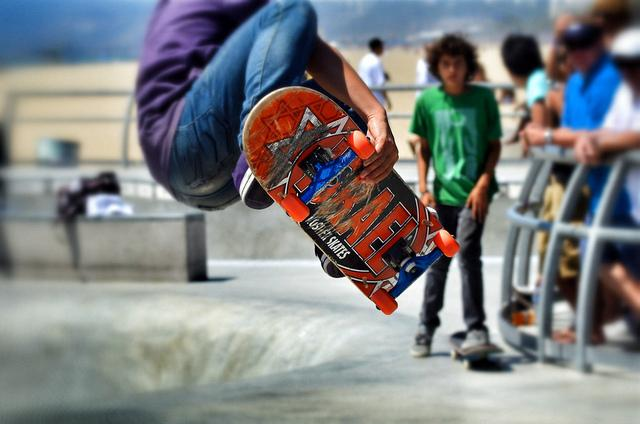Why is the boy wearing purple touching the bottom of the skateboard? Please explain your reasoning. performing tricks. He is performing stunts. 